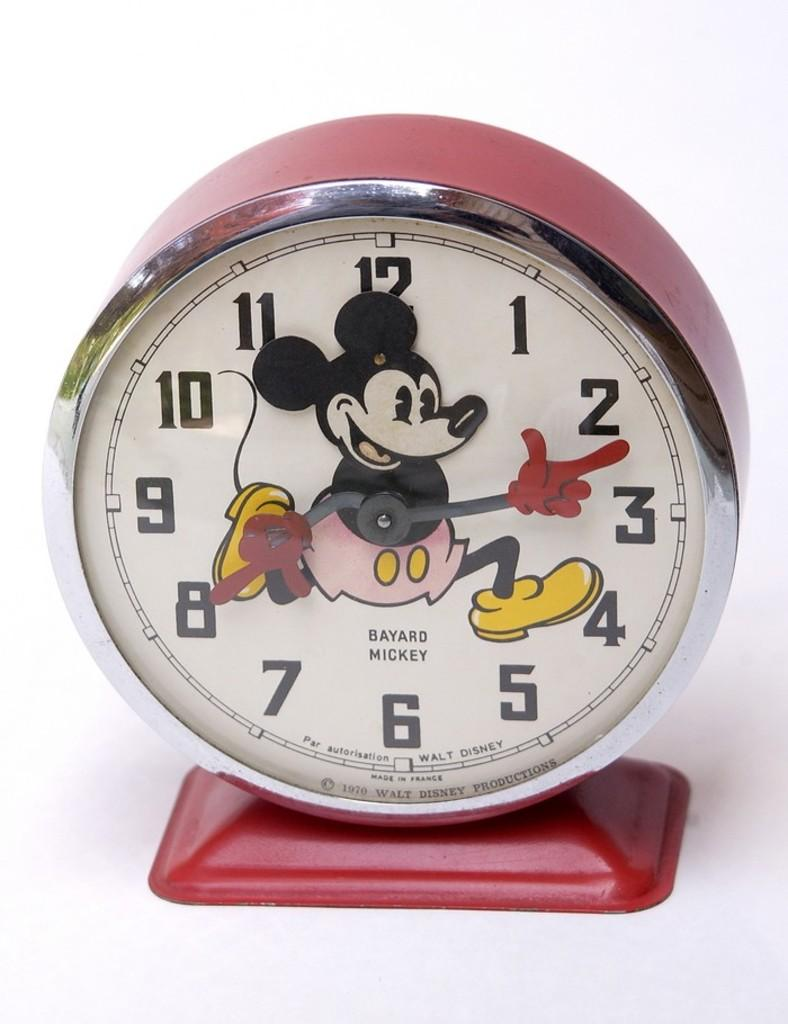<image>
Create a compact narrative representing the image presented. A Mickey Mouse clock has the words Bayard Mickey on the face. 